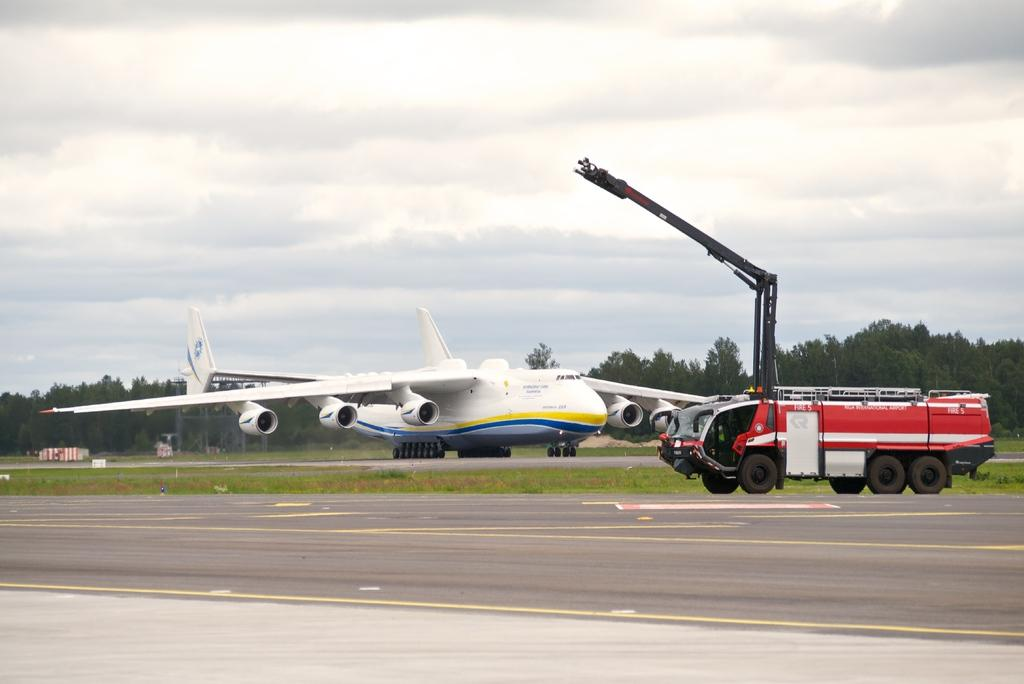What is the main subject of the image? The main subject of the image is a flight. Can you describe the location of the flight? The flight is on a runway, as there is a vehicle present on the runway. What type of natural environment can be seen in the image? Grass and trees are visible in the image. Are there any structures in the image? Yes, there are small stands in the image. What is visible in the sky? Clouds are present in the sky. How many friends can be seen playing on the grass in the image? There are no friends or people playing on the grass in the image; it only shows a flight, a vehicle, grass, trees, small stands, and clouds. Can you tell me how many times the person jumps in the image? There is no person or jumping activity depicted in the image. 